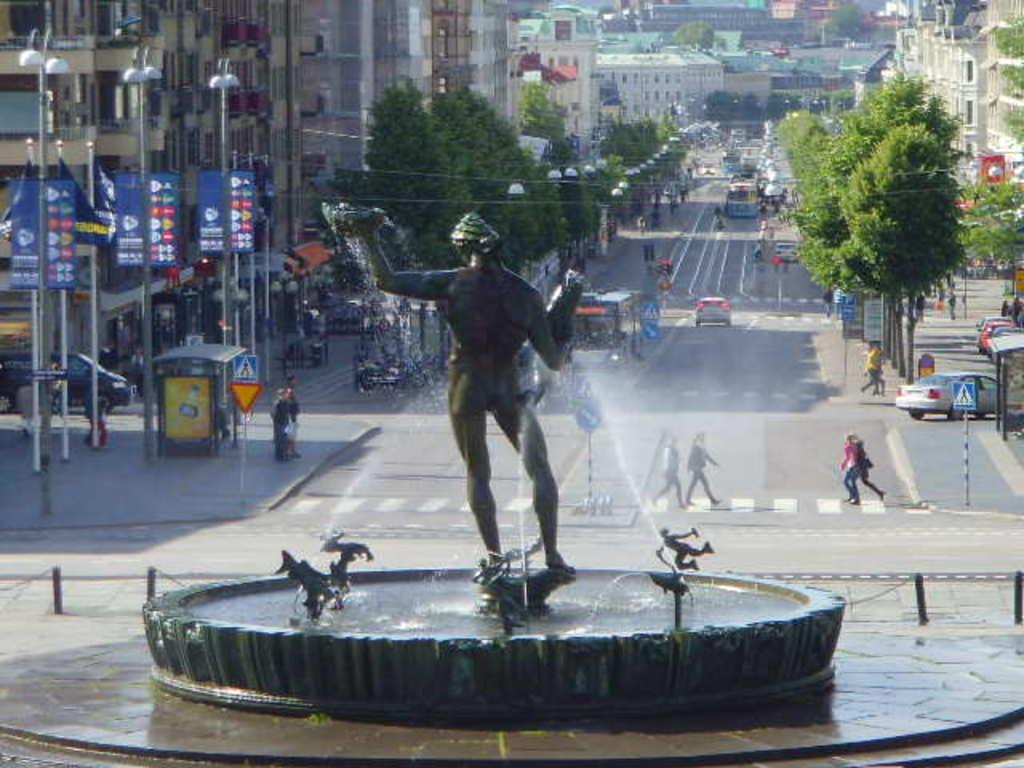What is the main feature in the image? There is a fountain in the image. What else can be seen in the image besides the fountain? There are buildings, trees, boards, poles, lights, people, vehicles, and poles with sign boards in the image. Can you describe the surroundings of the fountain? The fountain is surrounded by buildings, trees, and poles with sign boards. What type of vehicles can be seen on the road in the image? There are vehicles on the road in the image, but the specific types of vehicles are not mentioned. Are there any people in the image? Yes, there are people in the image. What type of curtain is hanging in the fountain in the image? There is no curtain present in the fountain or the image. How many selections of ice cream flavors are available at the fountain in the image? There is no mention of ice cream or any selections in the image. 